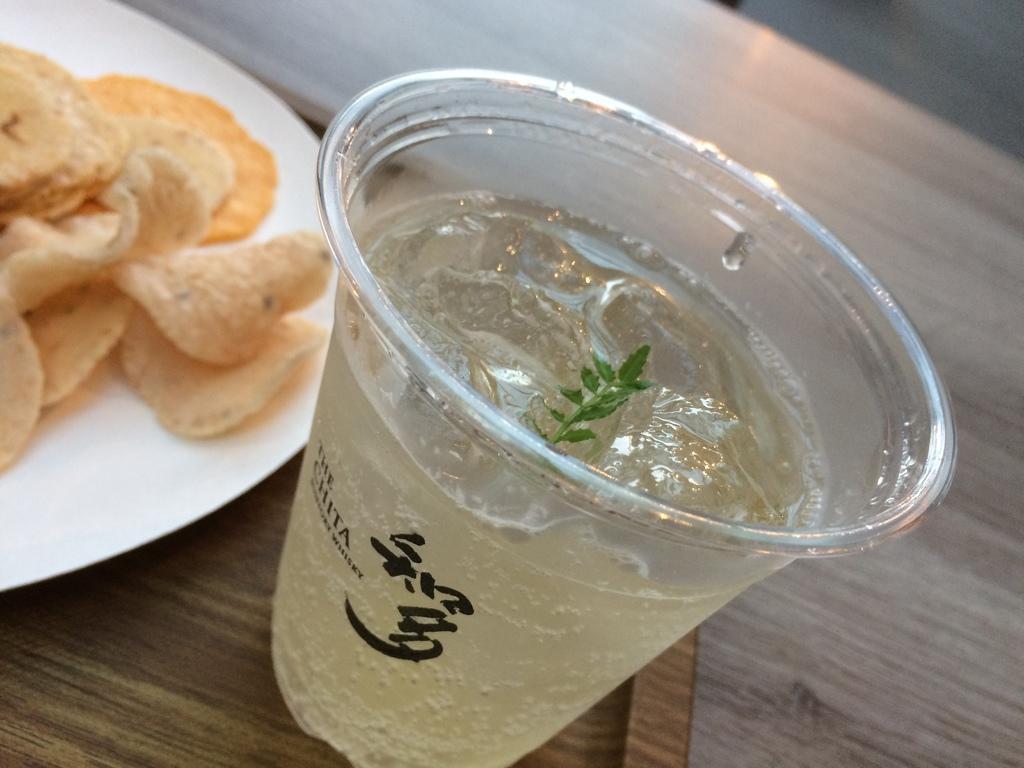Can you describe this image briefly? In this image we can see some chips on the plate and some juice in a glass are on the brown plate. There is one big table and brown plate is on the table. 